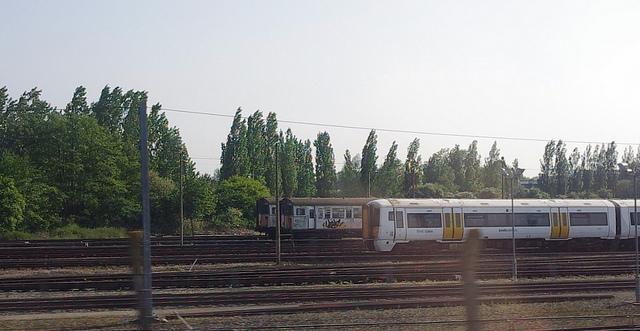Is this train ready to transport people?
Short answer required. Yes. Are there leaves on the trees?
Short answer required. Yes. What type of material fence is keeping them in?
Be succinct. Metal. Are this racing cars?
Keep it brief. No. Is the train moving?
Short answer required. Yes. Are the train tracks straight?
Write a very short answer. Yes. What type of trees are these?
Answer briefly. Pine. How many train tracks are there?
Short answer required. 4. Are there a lot of trees?
Write a very short answer. Yes. Is there a city in the background of this picture?
Be succinct. No. 